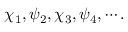<formula> <loc_0><loc_0><loc_500><loc_500>\chi _ { 1 } , \psi _ { 2 } , \chi _ { 3 } , \psi _ { 4 } , \cdots .</formula> 